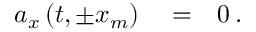Convert formula to latex. <formula><loc_0><loc_0><loc_500><loc_500>\begin{array} { r l r } { a _ { x } \left ( t , \pm x _ { m } \right ) } & = } & { 0 \, . } \end{array}</formula> 